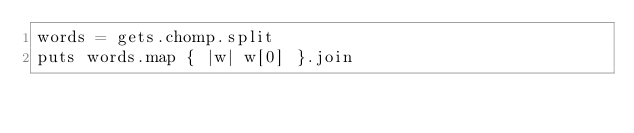Convert code to text. <code><loc_0><loc_0><loc_500><loc_500><_Ruby_>words = gets.chomp.split
puts words.map { |w| w[0] }.join
</code> 